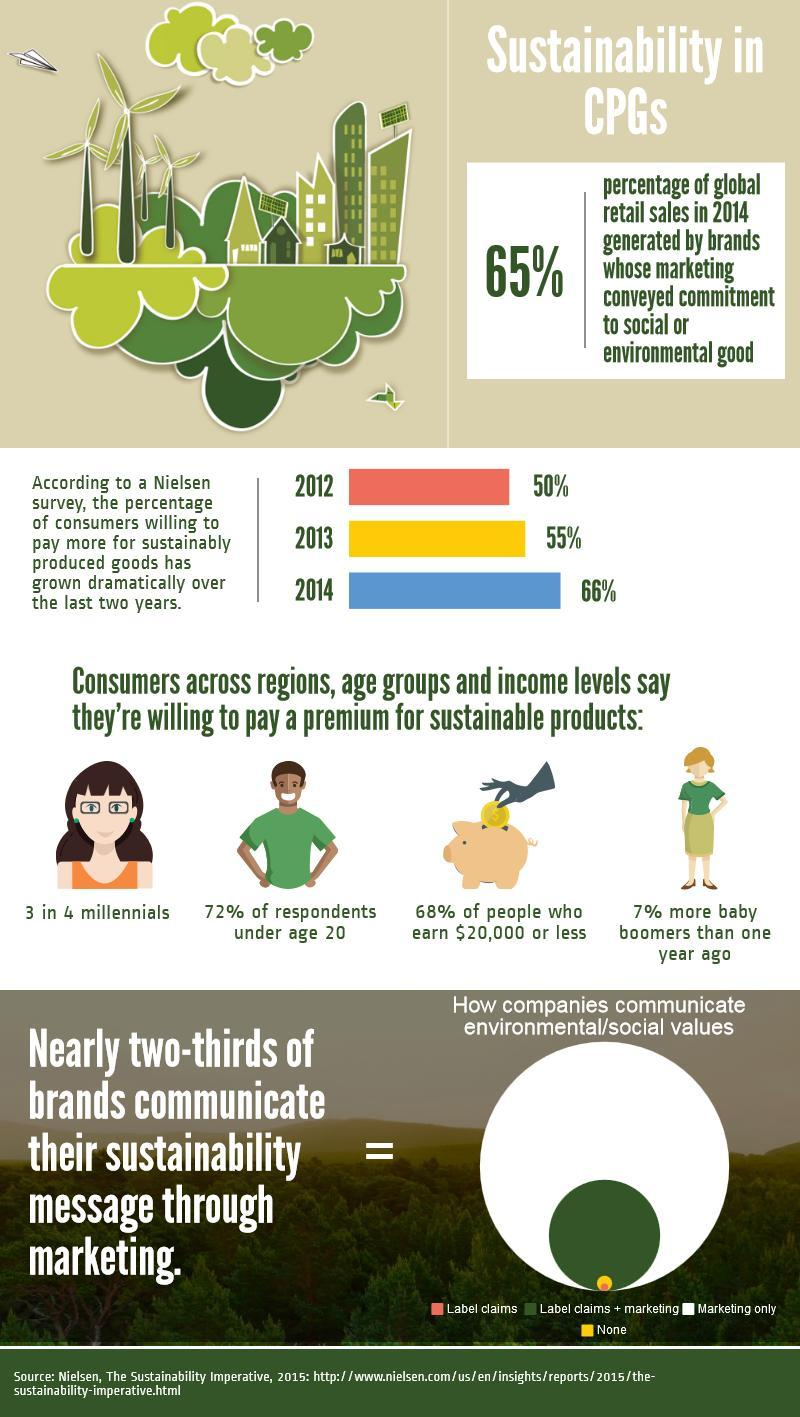What is the percentage of consumers willing to pay more for sustainably produced goods in the year 2012 and 2013, taken together?
Answer the question with a short phrase. 105% What percentage of respondents are not under the age of 20? 28% What is the percentage of consumers willing to pay more for sustainably produced goods in the year 2014 and 2013, taken together? 121% 